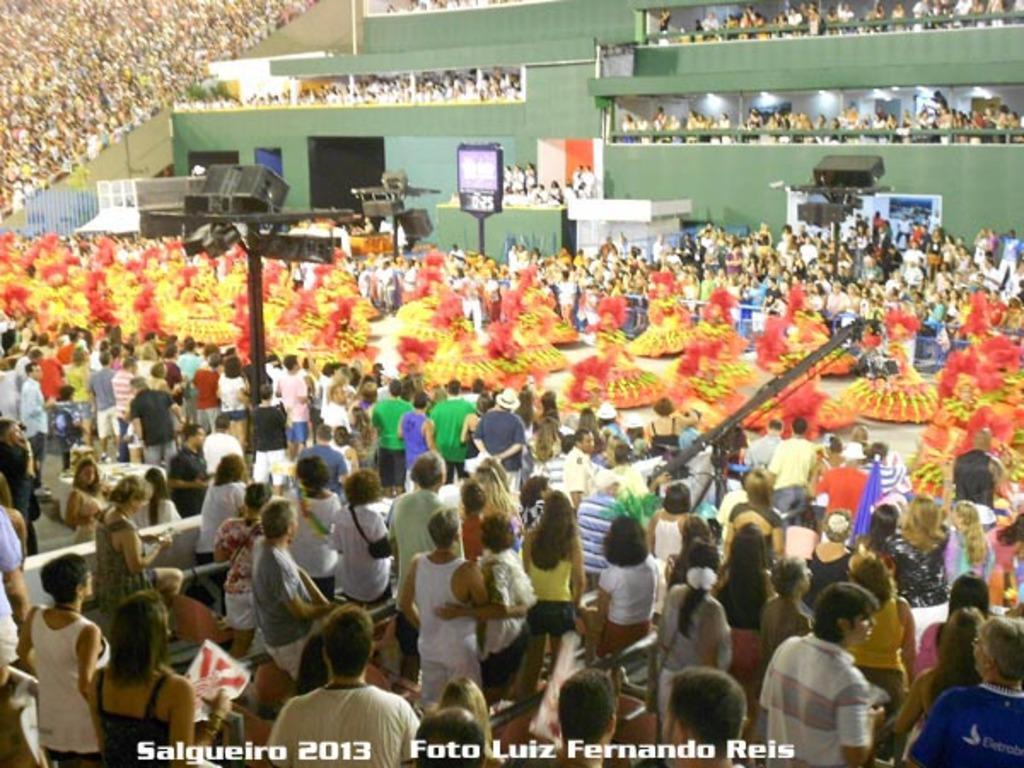In one or two sentences, can you explain what this image depicts? In the center of the image we can see people performing. They are all wearing same costumes and we can see crowd. On the left there is a speaker placed on the stand and there is a screen. 